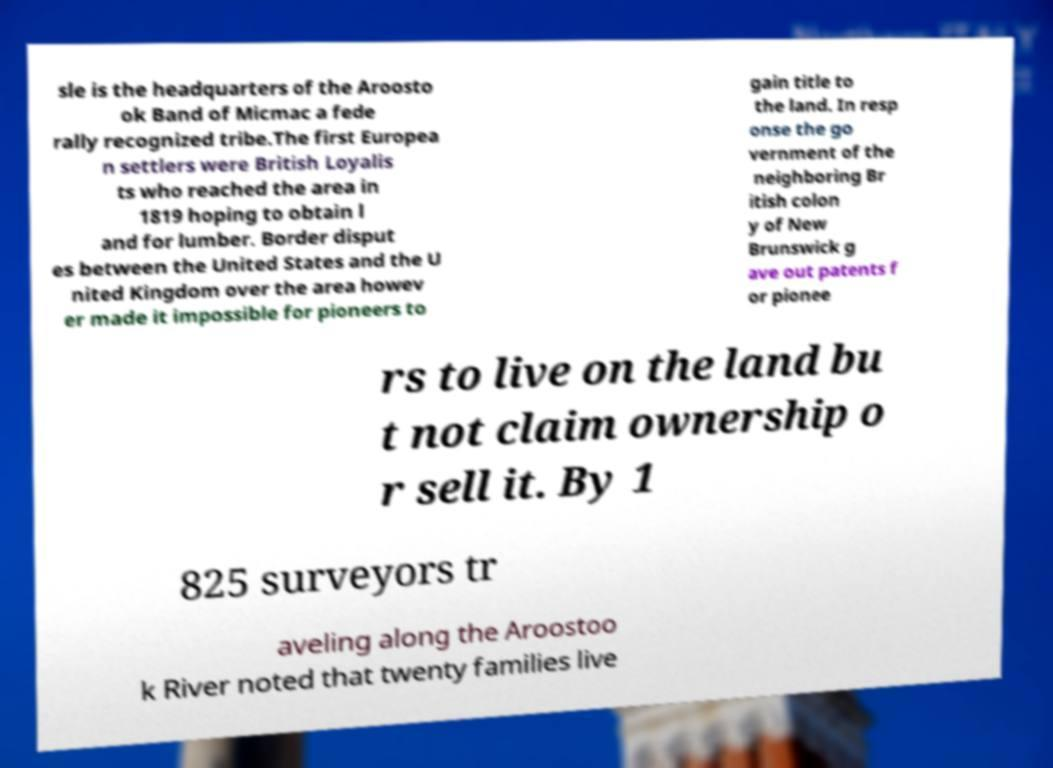Please read and relay the text visible in this image. What does it say? sle is the headquarters of the Aroosto ok Band of Micmac a fede rally recognized tribe.The first Europea n settlers were British Loyalis ts who reached the area in 1819 hoping to obtain l and for lumber. Border disput es between the United States and the U nited Kingdom over the area howev er made it impossible for pioneers to gain title to the land. In resp onse the go vernment of the neighboring Br itish colon y of New Brunswick g ave out patents f or pionee rs to live on the land bu t not claim ownership o r sell it. By 1 825 surveyors tr aveling along the Aroostoo k River noted that twenty families live 